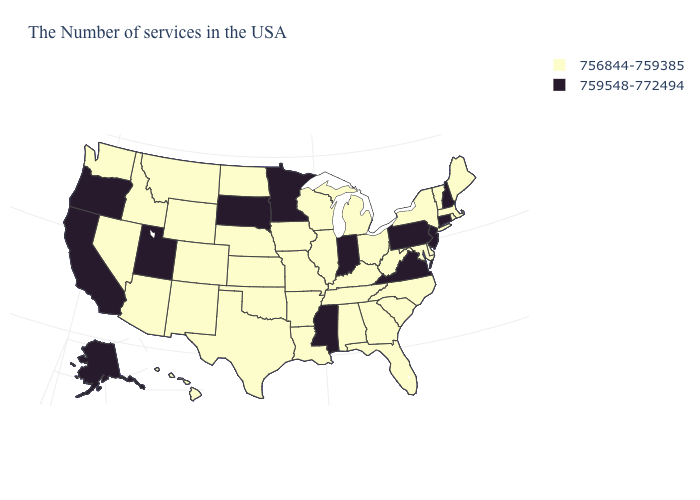Does the map have missing data?
Quick response, please. No. Which states hav the highest value in the West?
Give a very brief answer. Utah, California, Oregon, Alaska. Which states have the highest value in the USA?
Write a very short answer. New Hampshire, Connecticut, New Jersey, Pennsylvania, Virginia, Indiana, Mississippi, Minnesota, South Dakota, Utah, California, Oregon, Alaska. Does the first symbol in the legend represent the smallest category?
Answer briefly. Yes. What is the lowest value in the USA?
Short answer required. 756844-759385. How many symbols are there in the legend?
Give a very brief answer. 2. Does Colorado have a lower value than Ohio?
Be succinct. No. Among the states that border Texas , which have the highest value?
Write a very short answer. Louisiana, Arkansas, Oklahoma, New Mexico. Is the legend a continuous bar?
Answer briefly. No. What is the highest value in the South ?
Be succinct. 759548-772494. Name the states that have a value in the range 759548-772494?
Be succinct. New Hampshire, Connecticut, New Jersey, Pennsylvania, Virginia, Indiana, Mississippi, Minnesota, South Dakota, Utah, California, Oregon, Alaska. Name the states that have a value in the range 759548-772494?
Concise answer only. New Hampshire, Connecticut, New Jersey, Pennsylvania, Virginia, Indiana, Mississippi, Minnesota, South Dakota, Utah, California, Oregon, Alaska. Does Georgia have a lower value than Minnesota?
Keep it brief. Yes. What is the lowest value in the USA?
Short answer required. 756844-759385. Does the first symbol in the legend represent the smallest category?
Give a very brief answer. Yes. 